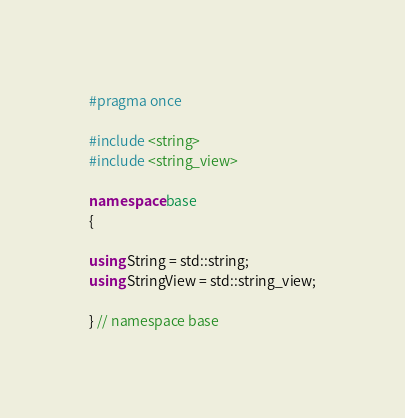Convert code to text. <code><loc_0><loc_0><loc_500><loc_500><_C++_>#pragma once

#include <string>
#include <string_view>

namespace base
{

using String = std::string;
using StringView = std::string_view;

} // namespace base
</code> 